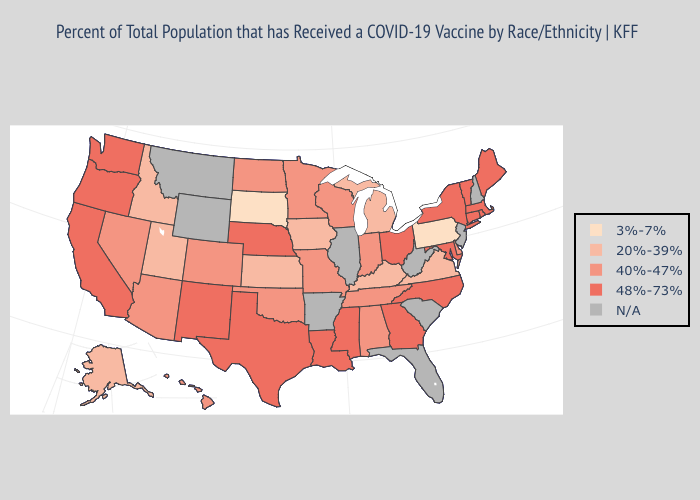Name the states that have a value in the range 48%-73%?
Be succinct. California, Connecticut, Georgia, Louisiana, Maine, Maryland, Massachusetts, Mississippi, Nebraska, New Mexico, New York, North Carolina, Ohio, Oregon, Rhode Island, Texas, Vermont, Washington. Does Indiana have the lowest value in the USA?
Write a very short answer. No. Name the states that have a value in the range N/A?
Write a very short answer. Arkansas, Florida, Illinois, Montana, New Hampshire, New Jersey, South Carolina, West Virginia, Wyoming. What is the value of California?
Concise answer only. 48%-73%. What is the lowest value in the USA?
Quick response, please. 3%-7%. Does New York have the highest value in the USA?
Short answer required. Yes. What is the lowest value in the USA?
Keep it brief. 3%-7%. Which states have the lowest value in the USA?
Concise answer only. Pennsylvania, South Dakota. Does Alaska have the highest value in the USA?
Short answer required. No. What is the value of Iowa?
Keep it brief. 20%-39%. Does the map have missing data?
Concise answer only. Yes. Name the states that have a value in the range 40%-47%?
Keep it brief. Alabama, Arizona, Colorado, Delaware, Hawaii, Indiana, Minnesota, Missouri, Nevada, North Dakota, Oklahoma, Tennessee, Wisconsin. What is the value of North Dakota?
Answer briefly. 40%-47%. What is the highest value in the South ?
Give a very brief answer. 48%-73%. 